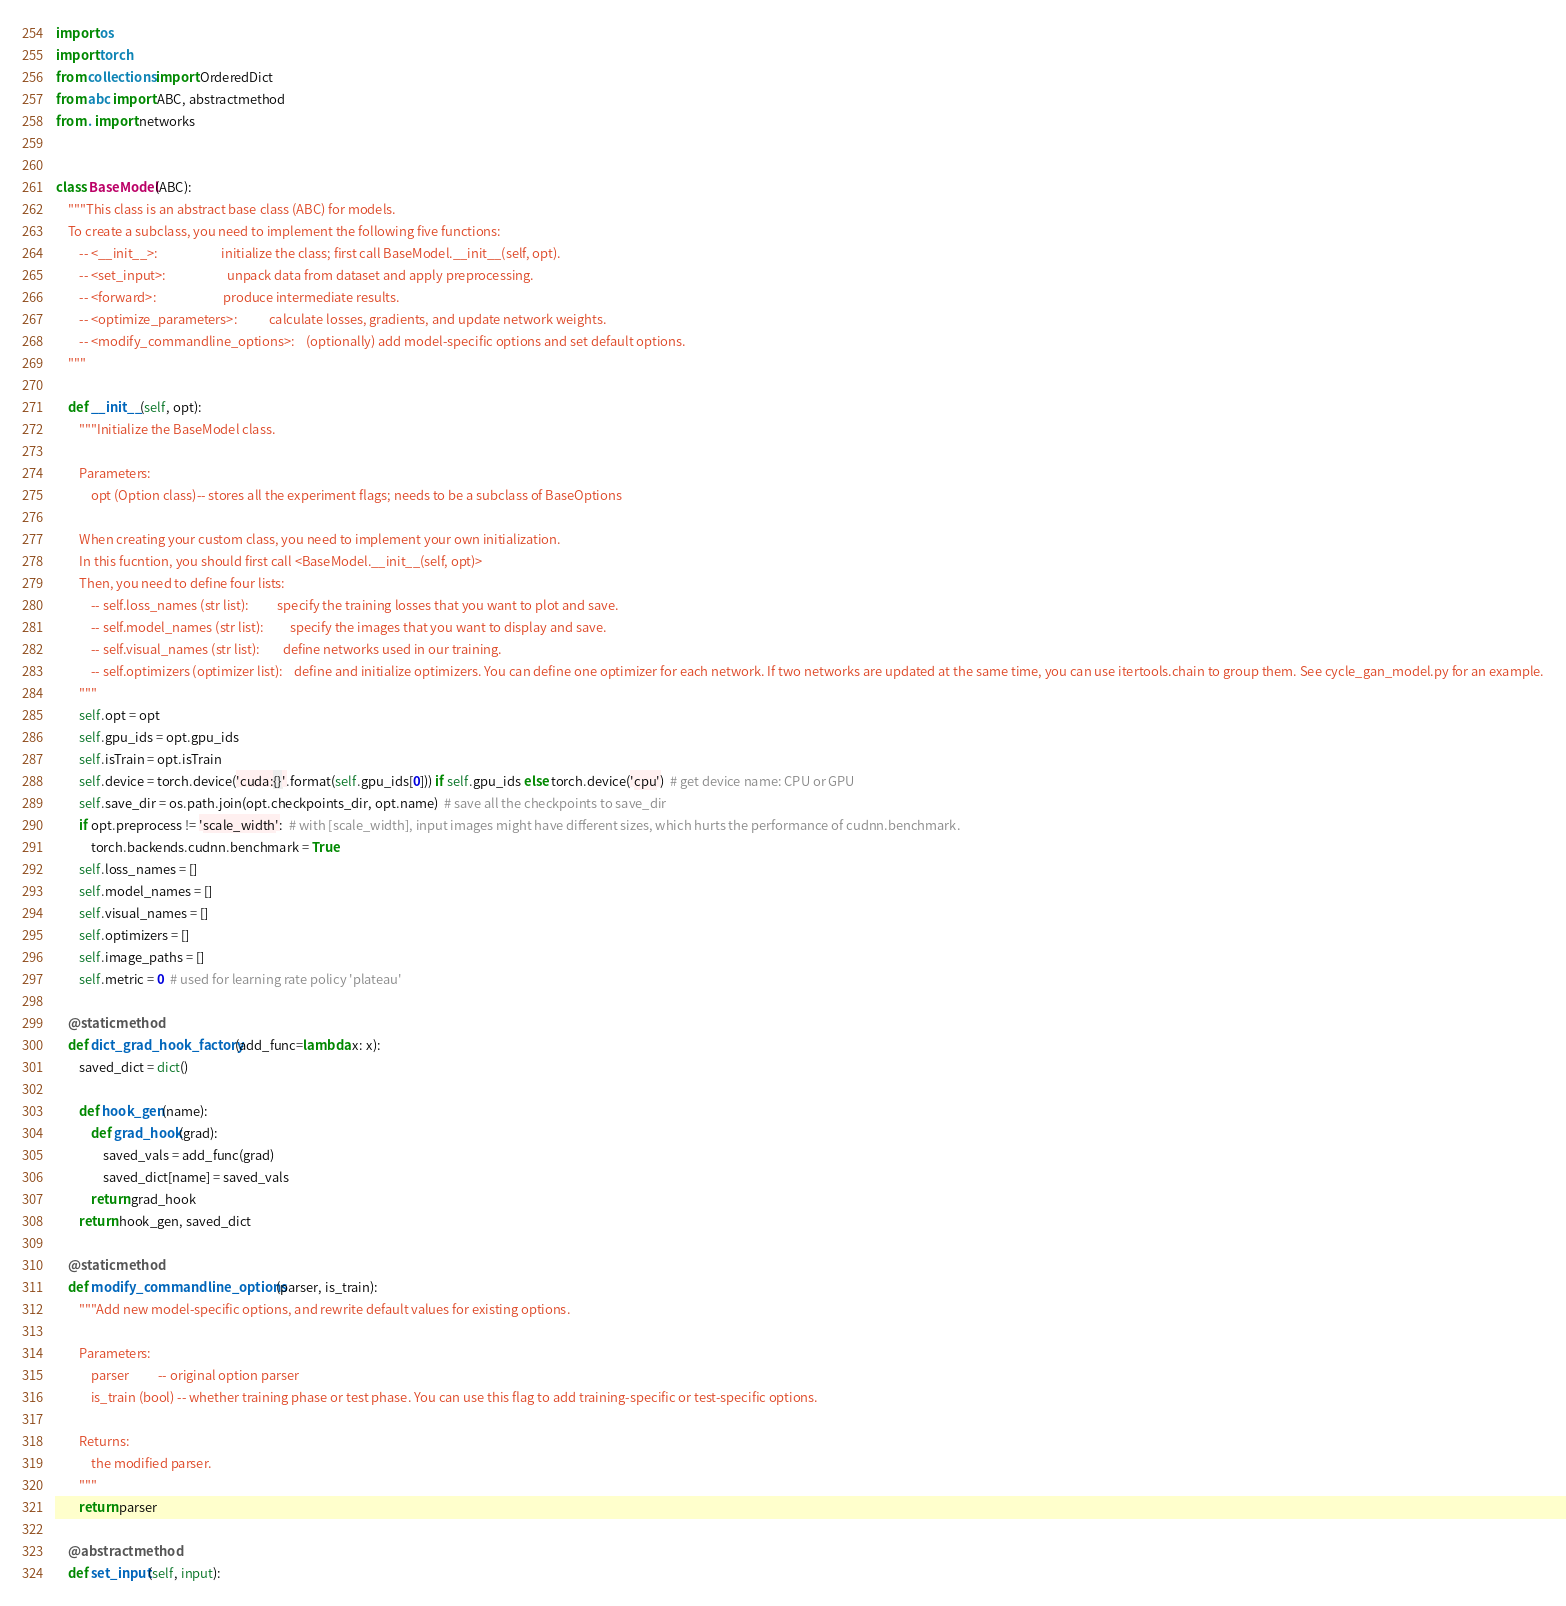Convert code to text. <code><loc_0><loc_0><loc_500><loc_500><_Python_>import os
import torch
from collections import OrderedDict
from abc import ABC, abstractmethod
from . import networks


class BaseModel(ABC):
    """This class is an abstract base class (ABC) for models.
    To create a subclass, you need to implement the following five functions:
        -- <__init__>:                      initialize the class; first call BaseModel.__init__(self, opt).
        -- <set_input>:                     unpack data from dataset and apply preprocessing.
        -- <forward>:                       produce intermediate results.
        -- <optimize_parameters>:           calculate losses, gradients, and update network weights.
        -- <modify_commandline_options>:    (optionally) add model-specific options and set default options.
    """

    def __init__(self, opt):
        """Initialize the BaseModel class.

        Parameters:
            opt (Option class)-- stores all the experiment flags; needs to be a subclass of BaseOptions

        When creating your custom class, you need to implement your own initialization.
        In this fucntion, you should first call <BaseModel.__init__(self, opt)>
        Then, you need to define four lists:
            -- self.loss_names (str list):          specify the training losses that you want to plot and save.
            -- self.model_names (str list):         specify the images that you want to display and save.
            -- self.visual_names (str list):        define networks used in our training.
            -- self.optimizers (optimizer list):    define and initialize optimizers. You can define one optimizer for each network. If two networks are updated at the same time, you can use itertools.chain to group them. See cycle_gan_model.py for an example.
        """
        self.opt = opt
        self.gpu_ids = opt.gpu_ids
        self.isTrain = opt.isTrain
        self.device = torch.device('cuda:{}'.format(self.gpu_ids[0])) if self.gpu_ids else torch.device('cpu')  # get device name: CPU or GPU
        self.save_dir = os.path.join(opt.checkpoints_dir, opt.name)  # save all the checkpoints to save_dir
        if opt.preprocess != 'scale_width':  # with [scale_width], input images might have different sizes, which hurts the performance of cudnn.benchmark.
            torch.backends.cudnn.benchmark = True
        self.loss_names = []
        self.model_names = []
        self.visual_names = []
        self.optimizers = []
        self.image_paths = []
        self.metric = 0  # used for learning rate policy 'plateau'

    @staticmethod
    def dict_grad_hook_factory(add_func=lambda x: x):
        saved_dict = dict()

        def hook_gen(name):
            def grad_hook(grad):
                saved_vals = add_func(grad)
                saved_dict[name] = saved_vals
            return grad_hook
        return hook_gen, saved_dict

    @staticmethod
    def modify_commandline_options(parser, is_train):
        """Add new model-specific options, and rewrite default values for existing options.

        Parameters:
            parser          -- original option parser
            is_train (bool) -- whether training phase or test phase. You can use this flag to add training-specific or test-specific options.

        Returns:
            the modified parser.
        """
        return parser

    @abstractmethod
    def set_input(self, input):</code> 